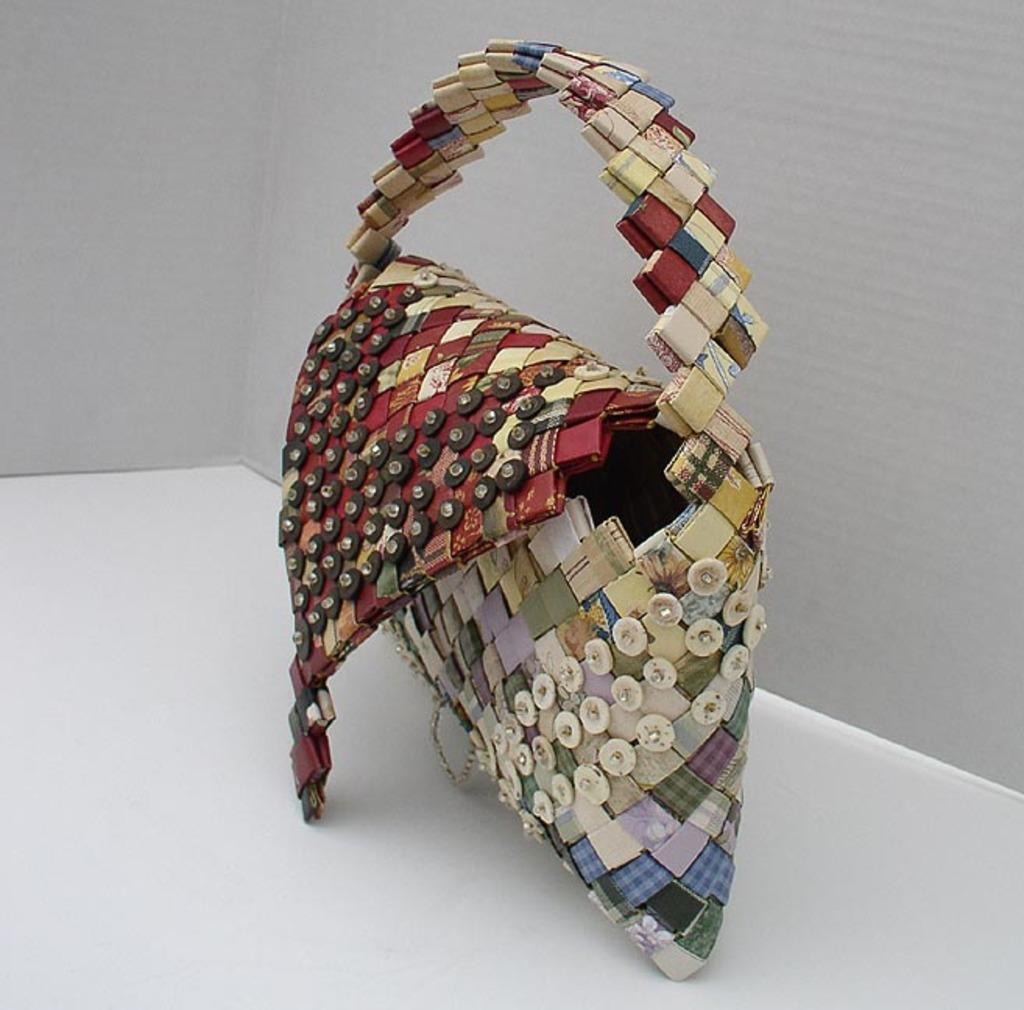What type of accessory is visible in the image? There is a handbag in the image. Is the handbag being used as a throne in the image? No, the handbag is not being used as a throne in the image. Is the person holding the handbag shown sleeping in the image? There is no person holding the handbag or shown sleeping in the image. 